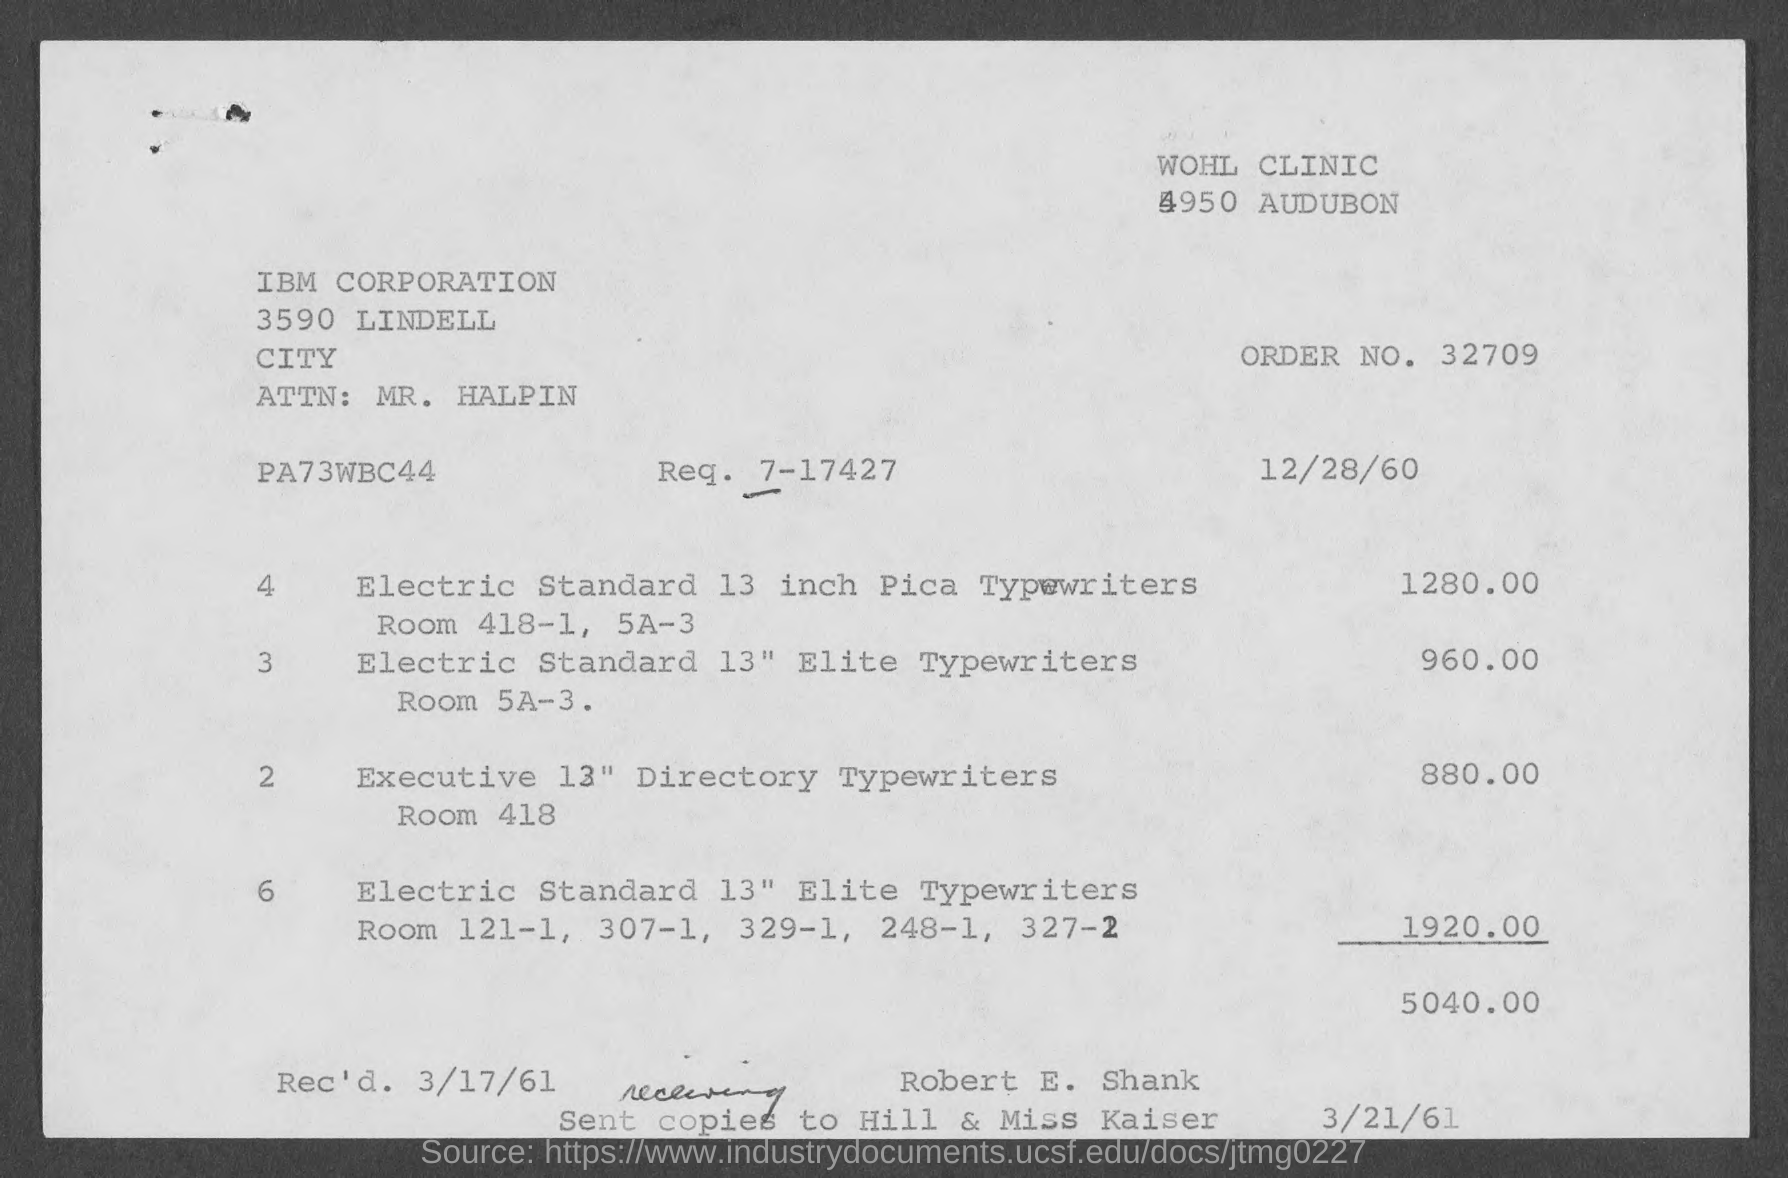What is the order no.?
Your answer should be very brief. 32709. What is the req. no?
Your response must be concise. 7-17427. 